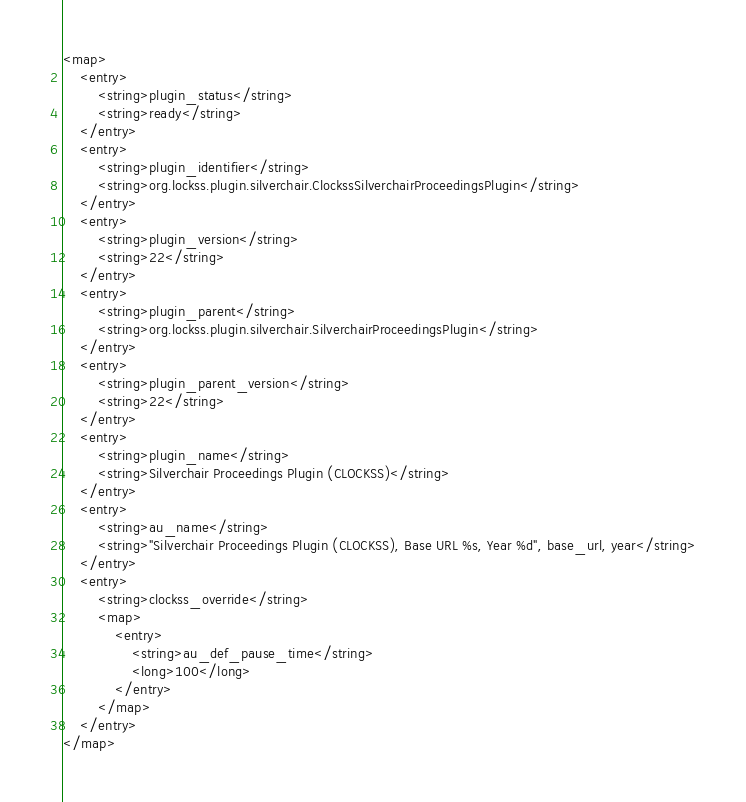<code> <loc_0><loc_0><loc_500><loc_500><_XML_><map>
    <entry>
        <string>plugin_status</string>
        <string>ready</string>
    </entry>
    <entry>
        <string>plugin_identifier</string>
        <string>org.lockss.plugin.silverchair.ClockssSilverchairProceedingsPlugin</string>
    </entry>
    <entry>
        <string>plugin_version</string>
        <string>22</string>
    </entry>
    <entry>
        <string>plugin_parent</string>
        <string>org.lockss.plugin.silverchair.SilverchairProceedingsPlugin</string>
    </entry>
    <entry>
        <string>plugin_parent_version</string>
        <string>22</string>
    </entry>
    <entry>
        <string>plugin_name</string>
        <string>Silverchair Proceedings Plugin (CLOCKSS)</string>
    </entry>
    <entry>
        <string>au_name</string>
        <string>"Silverchair Proceedings Plugin (CLOCKSS), Base URL %s, Year %d", base_url, year</string>
    </entry>
    <entry>
        <string>clockss_override</string>
        <map>
            <entry>
                <string>au_def_pause_time</string>
                <long>100</long>
            </entry>
        </map>
    </entry>
</map>
</code> 